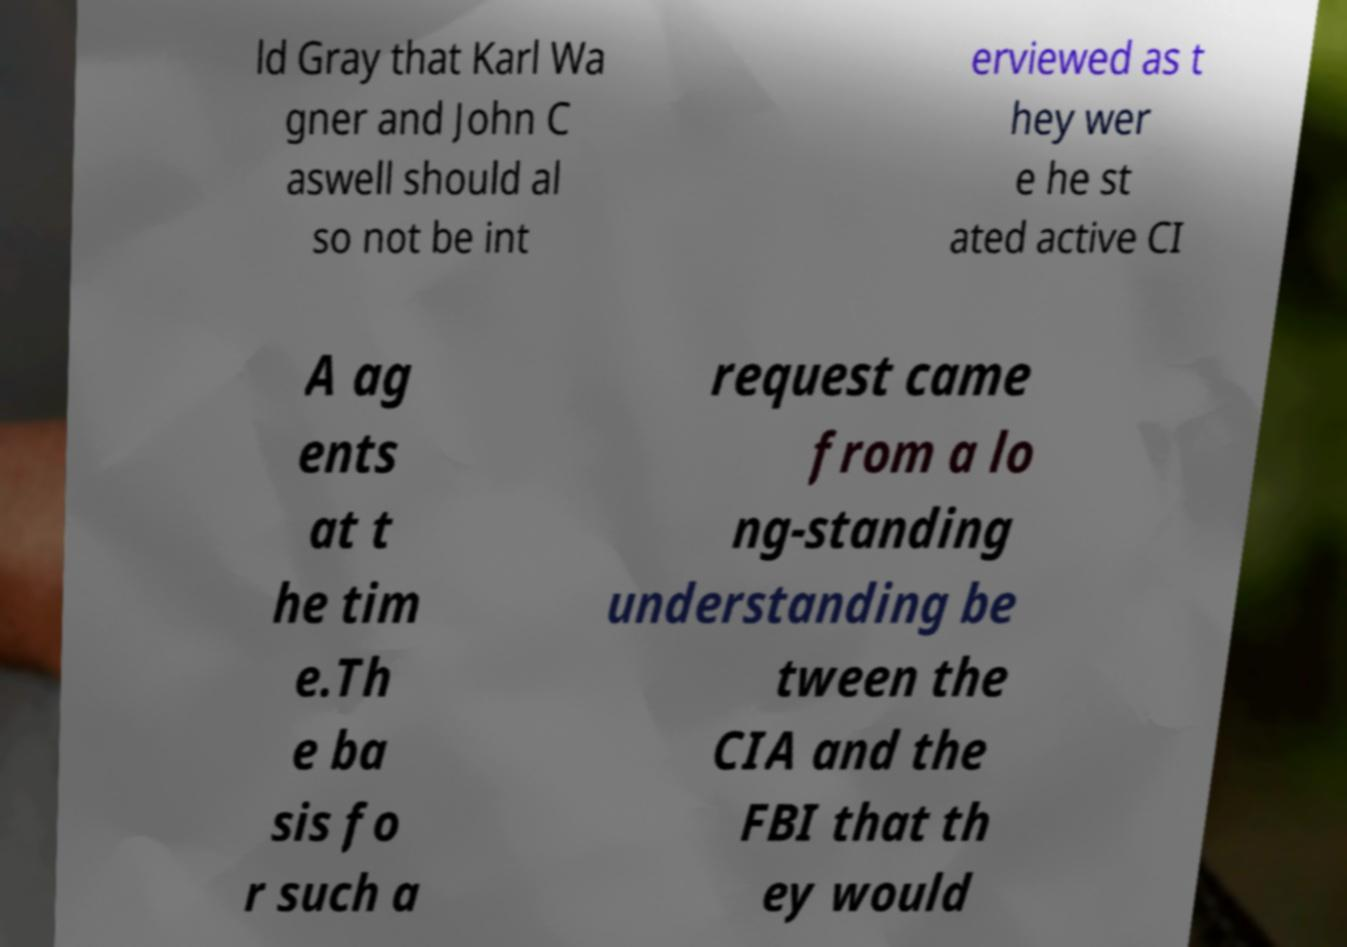Please read and relay the text visible in this image. What does it say? ld Gray that Karl Wa gner and John C aswell should al so not be int erviewed as t hey wer e he st ated active CI A ag ents at t he tim e.Th e ba sis fo r such a request came from a lo ng-standing understanding be tween the CIA and the FBI that th ey would 